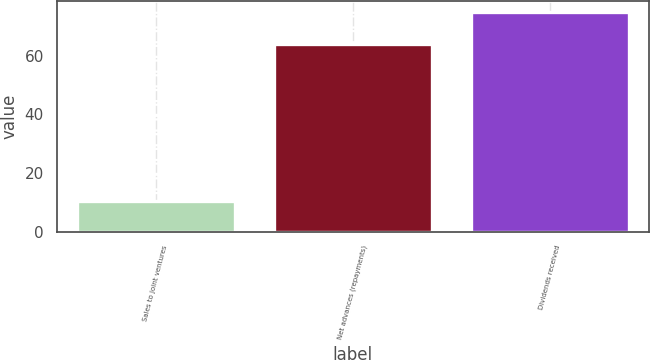Convert chart. <chart><loc_0><loc_0><loc_500><loc_500><bar_chart><fcel>Sales to joint ventures<fcel>Net advances (repayments)<fcel>Dividends received<nl><fcel>10.5<fcel>63.9<fcel>75.1<nl></chart> 